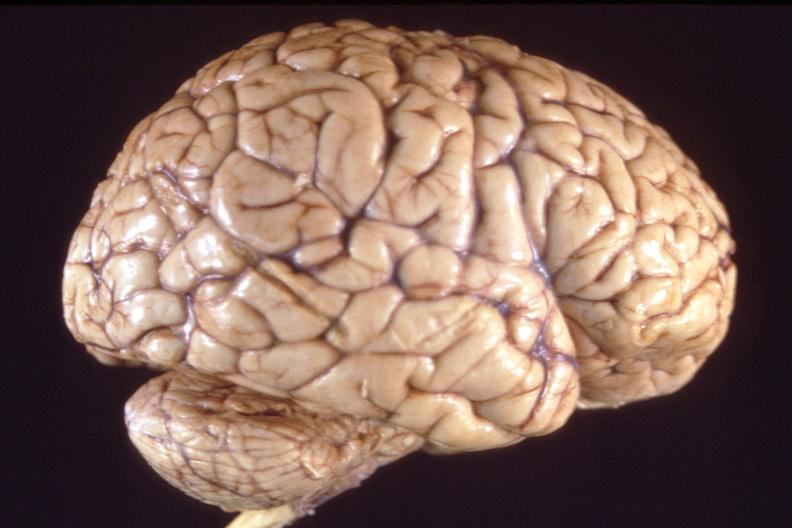what is present?
Answer the question using a single word or phrase. Nervous 